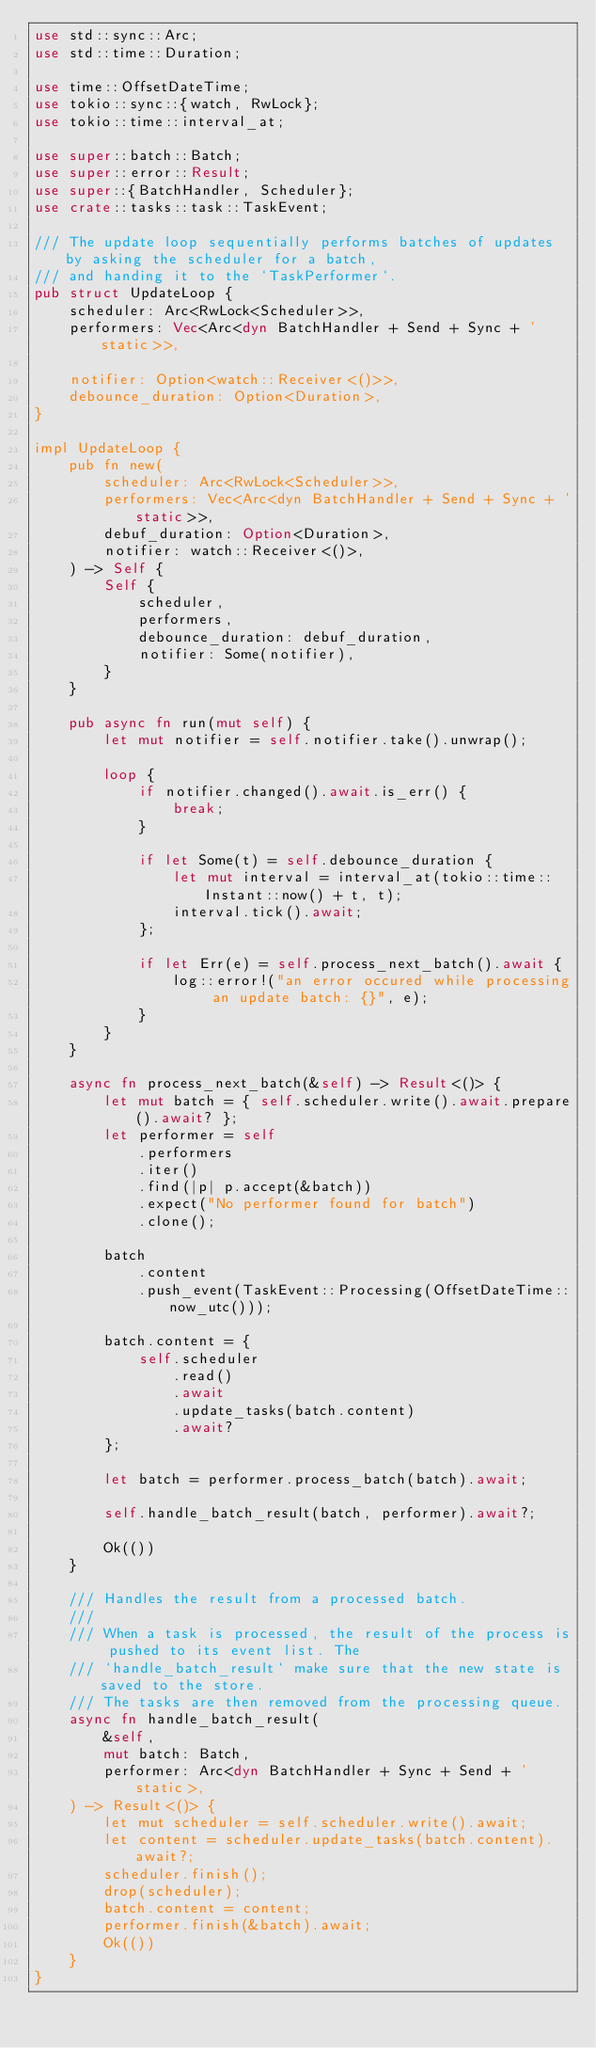Convert code to text. <code><loc_0><loc_0><loc_500><loc_500><_Rust_>use std::sync::Arc;
use std::time::Duration;

use time::OffsetDateTime;
use tokio::sync::{watch, RwLock};
use tokio::time::interval_at;

use super::batch::Batch;
use super::error::Result;
use super::{BatchHandler, Scheduler};
use crate::tasks::task::TaskEvent;

/// The update loop sequentially performs batches of updates by asking the scheduler for a batch,
/// and handing it to the `TaskPerformer`.
pub struct UpdateLoop {
    scheduler: Arc<RwLock<Scheduler>>,
    performers: Vec<Arc<dyn BatchHandler + Send + Sync + 'static>>,

    notifier: Option<watch::Receiver<()>>,
    debounce_duration: Option<Duration>,
}

impl UpdateLoop {
    pub fn new(
        scheduler: Arc<RwLock<Scheduler>>,
        performers: Vec<Arc<dyn BatchHandler + Send + Sync + 'static>>,
        debuf_duration: Option<Duration>,
        notifier: watch::Receiver<()>,
    ) -> Self {
        Self {
            scheduler,
            performers,
            debounce_duration: debuf_duration,
            notifier: Some(notifier),
        }
    }

    pub async fn run(mut self) {
        let mut notifier = self.notifier.take().unwrap();

        loop {
            if notifier.changed().await.is_err() {
                break;
            }

            if let Some(t) = self.debounce_duration {
                let mut interval = interval_at(tokio::time::Instant::now() + t, t);
                interval.tick().await;
            };

            if let Err(e) = self.process_next_batch().await {
                log::error!("an error occured while processing an update batch: {}", e);
            }
        }
    }

    async fn process_next_batch(&self) -> Result<()> {
        let mut batch = { self.scheduler.write().await.prepare().await? };
        let performer = self
            .performers
            .iter()
            .find(|p| p.accept(&batch))
            .expect("No performer found for batch")
            .clone();

        batch
            .content
            .push_event(TaskEvent::Processing(OffsetDateTime::now_utc()));

        batch.content = {
            self.scheduler
                .read()
                .await
                .update_tasks(batch.content)
                .await?
        };

        let batch = performer.process_batch(batch).await;

        self.handle_batch_result(batch, performer).await?;

        Ok(())
    }

    /// Handles the result from a processed batch.
    ///
    /// When a task is processed, the result of the process is pushed to its event list. The
    /// `handle_batch_result` make sure that the new state is saved to the store.
    /// The tasks are then removed from the processing queue.
    async fn handle_batch_result(
        &self,
        mut batch: Batch,
        performer: Arc<dyn BatchHandler + Sync + Send + 'static>,
    ) -> Result<()> {
        let mut scheduler = self.scheduler.write().await;
        let content = scheduler.update_tasks(batch.content).await?;
        scheduler.finish();
        drop(scheduler);
        batch.content = content;
        performer.finish(&batch).await;
        Ok(())
    }
}
</code> 